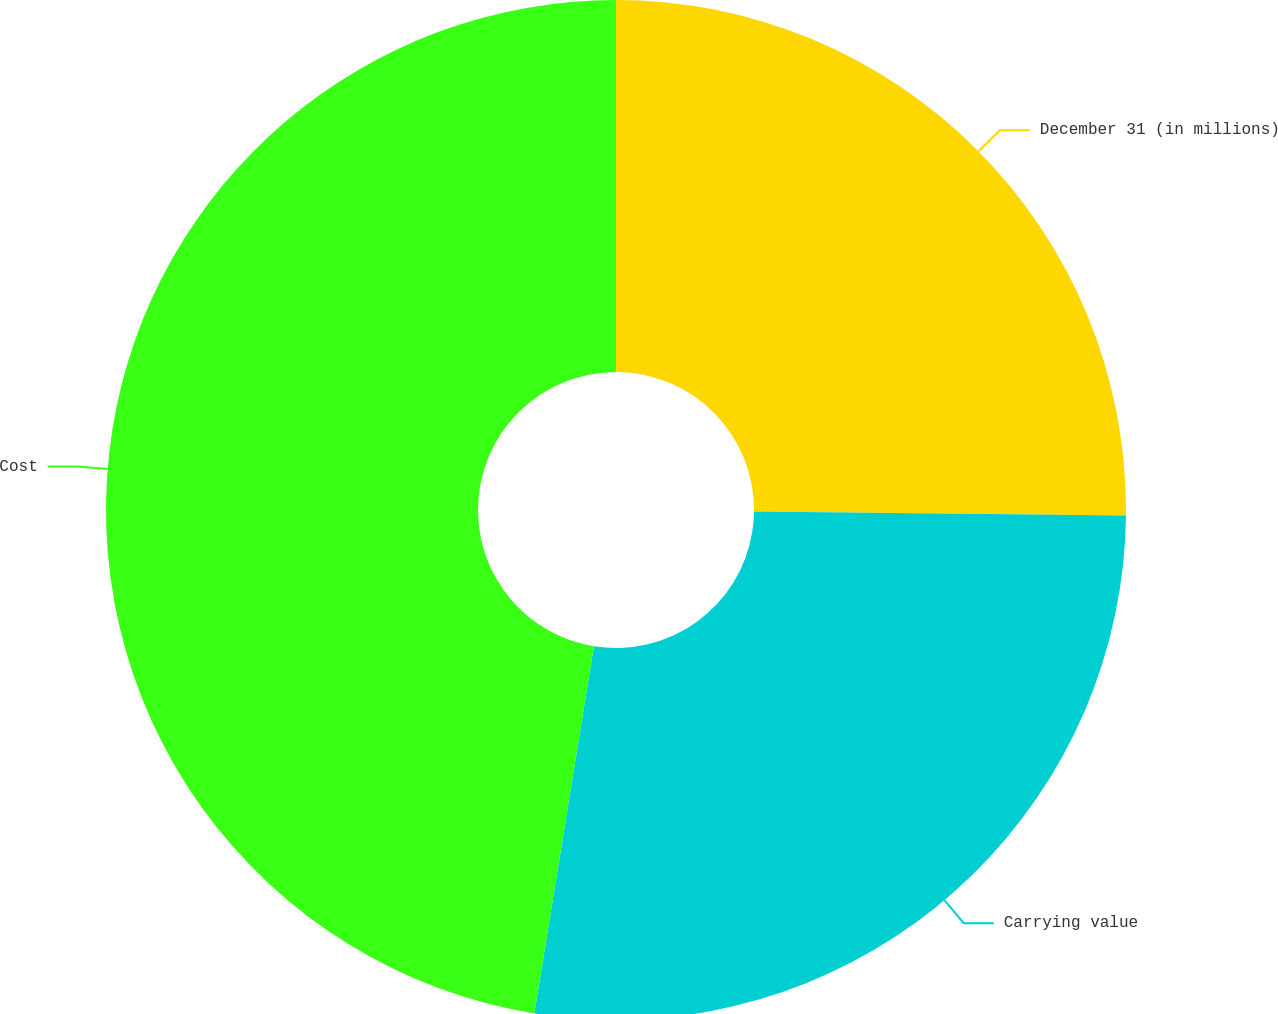Convert chart. <chart><loc_0><loc_0><loc_500><loc_500><pie_chart><fcel>December 31 (in millions)<fcel>Carrying value<fcel>Cost<nl><fcel>25.17%<fcel>27.39%<fcel>47.44%<nl></chart> 